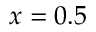Convert formula to latex. <formula><loc_0><loc_0><loc_500><loc_500>x = 0 . 5</formula> 